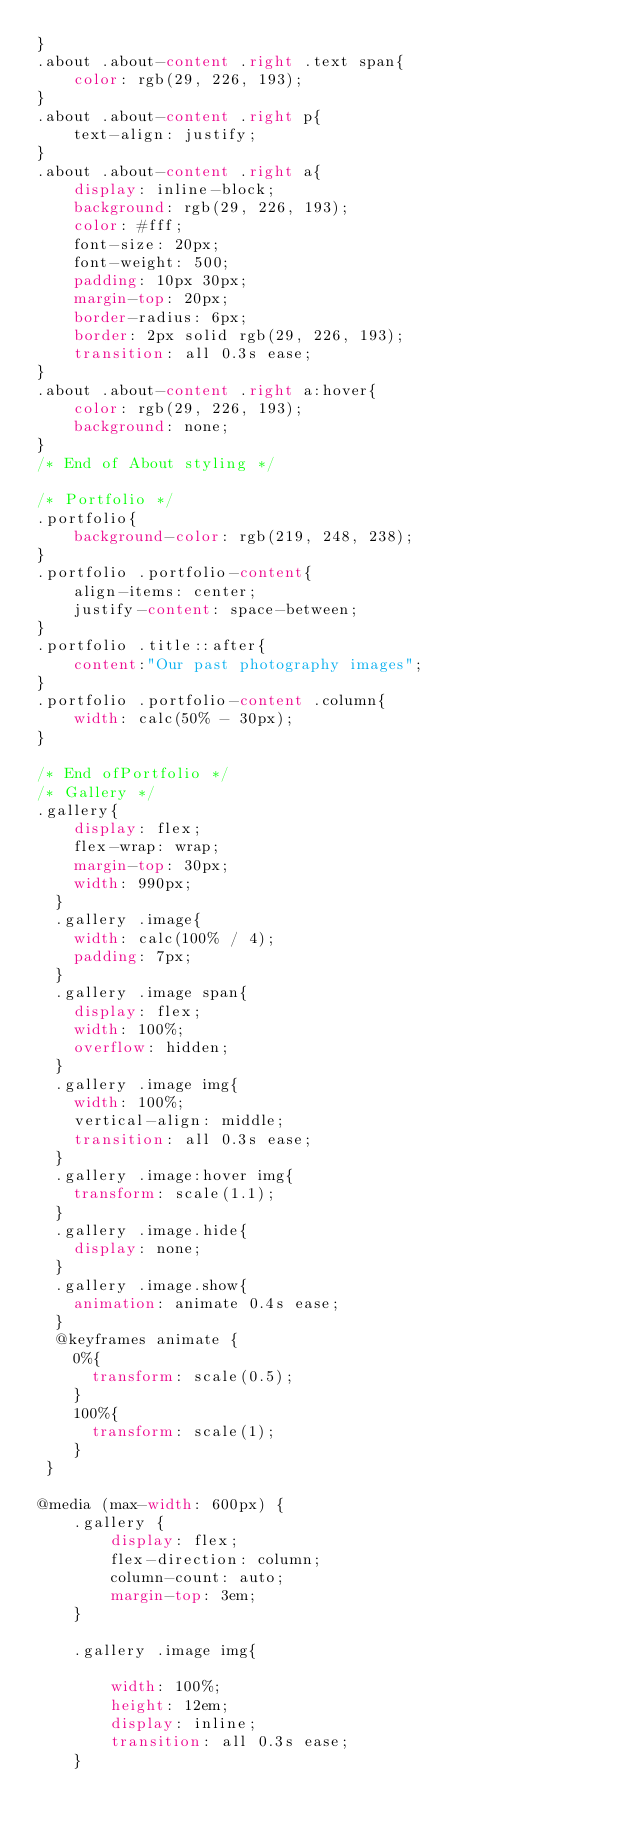<code> <loc_0><loc_0><loc_500><loc_500><_CSS_>}
.about .about-content .right .text span{
    color: rgb(29, 226, 193);
}
.about .about-content .right p{
    text-align: justify;
}
.about .about-content .right a{
    display: inline-block;
    background: rgb(29, 226, 193);
    color: #fff;
    font-size: 20px;
    font-weight: 500;
    padding: 10px 30px;
    margin-top: 20px;
    border-radius: 6px;
    border: 2px solid rgb(29, 226, 193);
    transition: all 0.3s ease;
}
.about .about-content .right a:hover{
    color: rgb(29, 226, 193);
    background: none;
}
/* End of About styling */

/* Portfolio */
.portfolio{
    background-color: rgb(219, 248, 238);
}
.portfolio .portfolio-content{
    align-items: center;
    justify-content: space-between;
}
.portfolio .title::after{
    content:"Our past photography images";
}
.portfolio .portfolio-content .column{
    width: calc(50% - 30px);
}

/* End ofPortfolio */
/* Gallery */
.gallery{
    display: flex;
    flex-wrap: wrap;
    margin-top: 30px;
    width: 990px;
  }
  .gallery .image{
    width: calc(100% / 4);
    padding: 7px;
  }
  .gallery .image span{
    display: flex;
    width: 100%;
    overflow: hidden;
  }
  .gallery .image img{
    width: 100%;
    vertical-align: middle;
    transition: all 0.3s ease;
  }
  .gallery .image:hover img{
    transform: scale(1.1);
  }
  .gallery .image.hide{
    display: none;
  }
  .gallery .image.show{
    animation: animate 0.4s ease;
  }
  @keyframes animate {
    0%{
      transform: scale(0.5);
    }
    100%{
      transform: scale(1);
    }
 }

@media (max-width: 600px) {
    .gallery {
        display: flex;
        flex-direction: column;
        column-count: auto; 
        margin-top: 3em;  
    }

    .gallery .image img{
        
        width: 100%;
        height: 12em;
        display: inline;
        transition: all 0.3s ease;
    }       </code> 